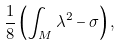<formula> <loc_0><loc_0><loc_500><loc_500>\frac { 1 } { 8 } \left ( \int _ { M } \lambda ^ { 2 } - \sigma \right ) ,</formula> 